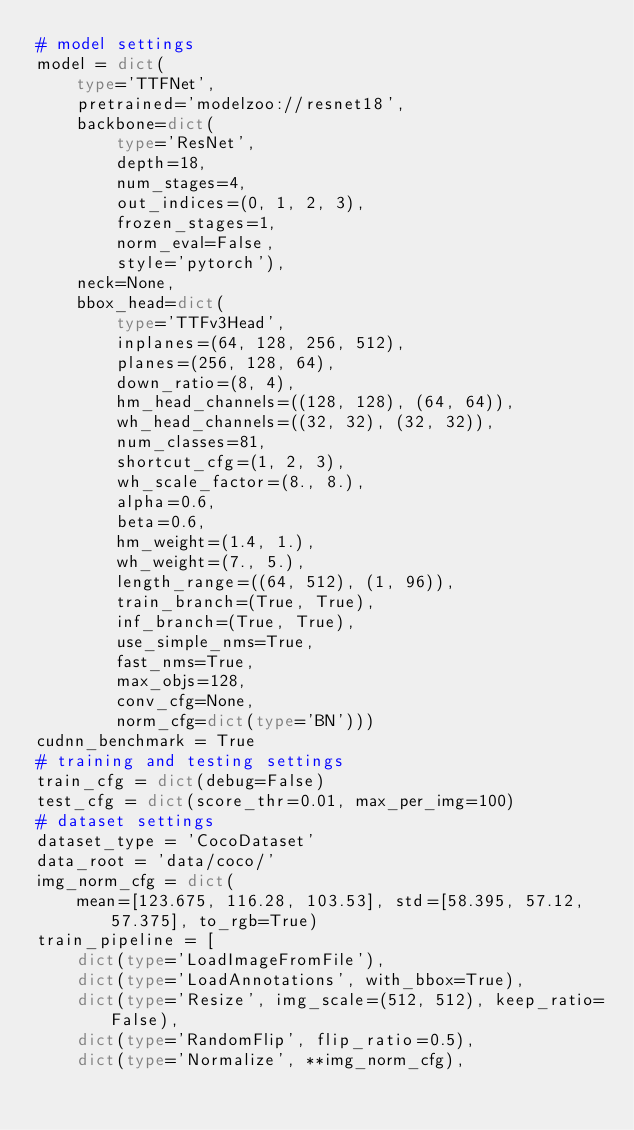<code> <loc_0><loc_0><loc_500><loc_500><_Python_># model settings
model = dict(
    type='TTFNet',
    pretrained='modelzoo://resnet18',
    backbone=dict(
        type='ResNet',
        depth=18,
        num_stages=4,
        out_indices=(0, 1, 2, 3),
        frozen_stages=1,
        norm_eval=False,
        style='pytorch'),
    neck=None,
    bbox_head=dict(
        type='TTFv3Head',
        inplanes=(64, 128, 256, 512),
        planes=(256, 128, 64),
        down_ratio=(8, 4),
        hm_head_channels=((128, 128), (64, 64)),
        wh_head_channels=((32, 32), (32, 32)),
        num_classes=81,
        shortcut_cfg=(1, 2, 3),
        wh_scale_factor=(8., 8.),
        alpha=0.6,
        beta=0.6,
        hm_weight=(1.4, 1.),
        wh_weight=(7., 5.),
        length_range=((64, 512), (1, 96)),
        train_branch=(True, True),
        inf_branch=(True, True),
        use_simple_nms=True,
        fast_nms=True,
        max_objs=128,
        conv_cfg=None,
        norm_cfg=dict(type='BN')))
cudnn_benchmark = True
# training and testing settings
train_cfg = dict(debug=False)
test_cfg = dict(score_thr=0.01, max_per_img=100)
# dataset settings
dataset_type = 'CocoDataset'
data_root = 'data/coco/'
img_norm_cfg = dict(
    mean=[123.675, 116.28, 103.53], std=[58.395, 57.12, 57.375], to_rgb=True)
train_pipeline = [
    dict(type='LoadImageFromFile'),
    dict(type='LoadAnnotations', with_bbox=True),
    dict(type='Resize', img_scale=(512, 512), keep_ratio=False),
    dict(type='RandomFlip', flip_ratio=0.5),
    dict(type='Normalize', **img_norm_cfg),</code> 